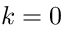<formula> <loc_0><loc_0><loc_500><loc_500>k = 0</formula> 